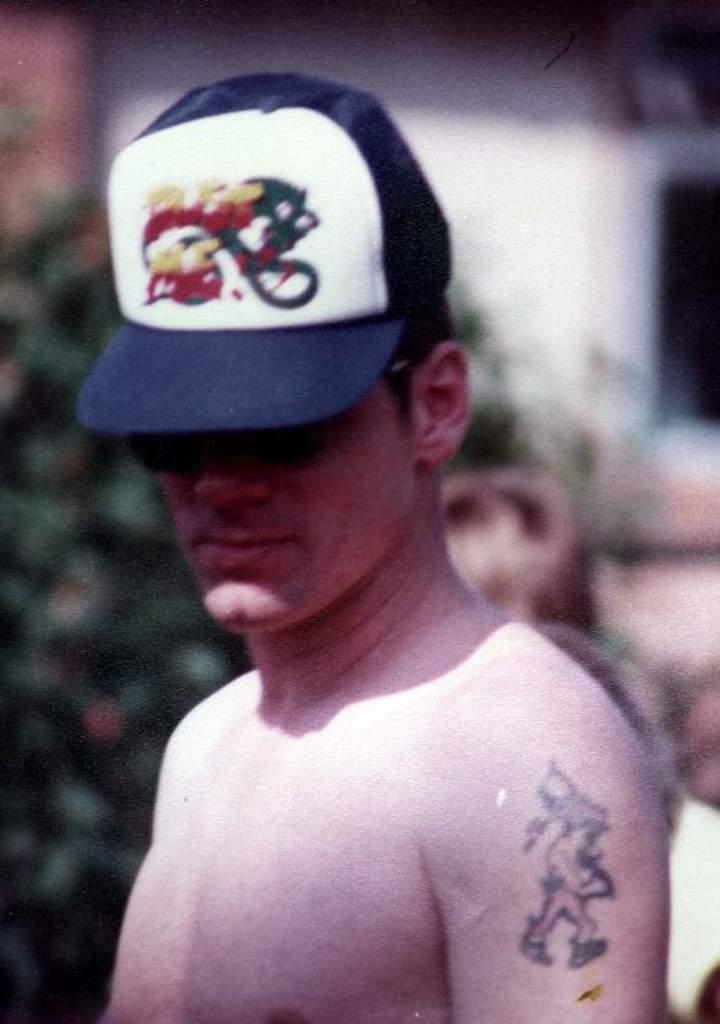What is the main subject of the image? The main subject of the image is a person. What type of headwear is the person wearing? The person is wearing a cap. What can be seen in the background of the image? There is a tree in the background of the image. What type of income does the person in the image earn? There is no information about the person's income in the image. Can you tell me how the person in the image is currently acting? The image does not provide information about the person's actions or behavior. 